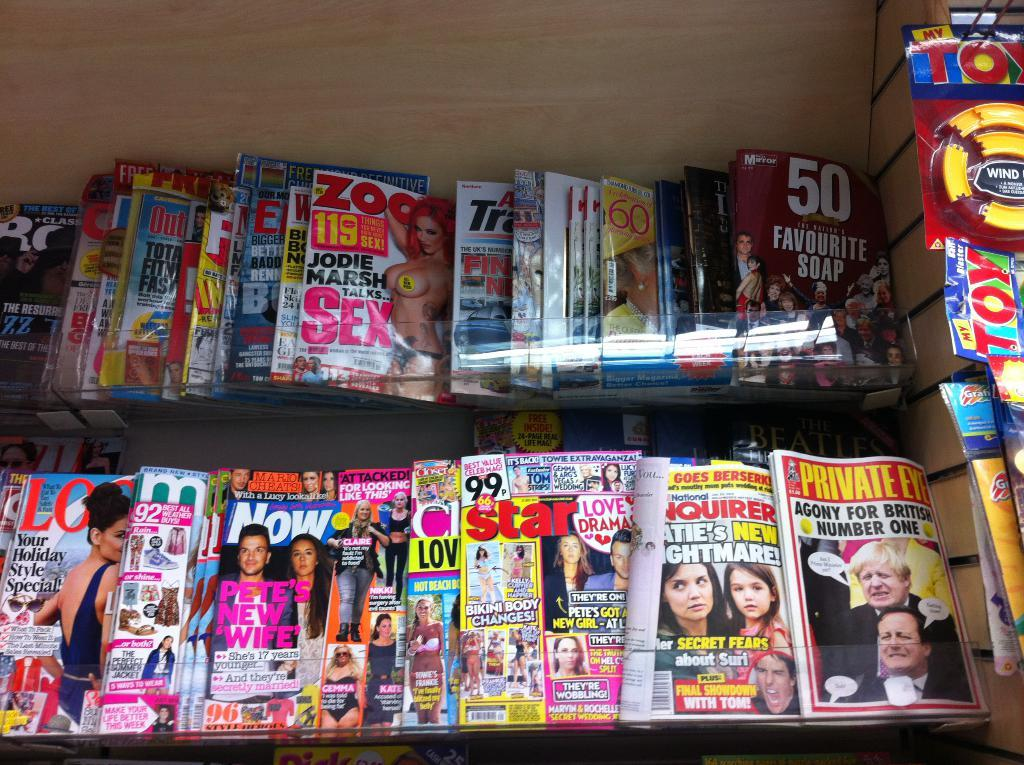What type of reading material is visible in the image? There are different types of magazines in the image. How are the magazines organized in the image? The magazines are kept in racks. What other items can be seen in the image besides the magazines? There are toys hanging on the wall in the image. Is there a stream visible in the image? No, there is no stream present in the image. Can you see a trail in the image? No, there is no trail visible in the image. 